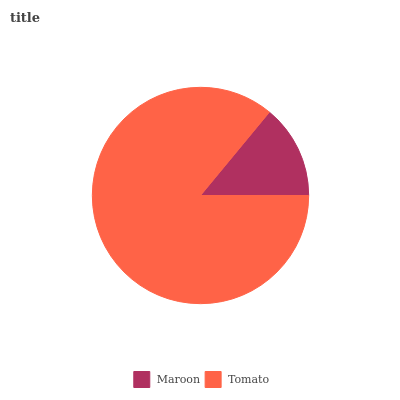Is Maroon the minimum?
Answer yes or no. Yes. Is Tomato the maximum?
Answer yes or no. Yes. Is Tomato the minimum?
Answer yes or no. No. Is Tomato greater than Maroon?
Answer yes or no. Yes. Is Maroon less than Tomato?
Answer yes or no. Yes. Is Maroon greater than Tomato?
Answer yes or no. No. Is Tomato less than Maroon?
Answer yes or no. No. Is Tomato the high median?
Answer yes or no. Yes. Is Maroon the low median?
Answer yes or no. Yes. Is Maroon the high median?
Answer yes or no. No. Is Tomato the low median?
Answer yes or no. No. 